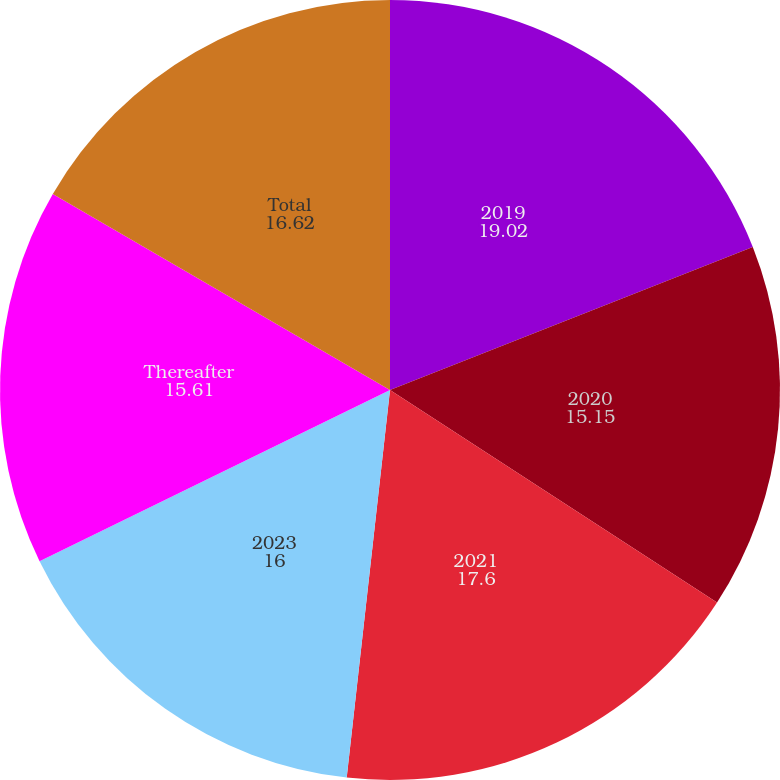Convert chart to OTSL. <chart><loc_0><loc_0><loc_500><loc_500><pie_chart><fcel>2019<fcel>2020<fcel>2021<fcel>2023<fcel>Thereafter<fcel>Total<nl><fcel>19.02%<fcel>15.15%<fcel>17.6%<fcel>16.0%<fcel>15.61%<fcel>16.62%<nl></chart> 